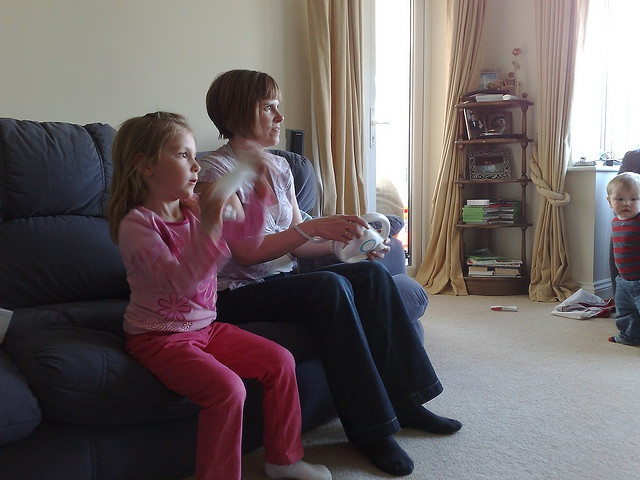Describe the objects in this image and their specific colors. I can see couch in darkgray, black, and gray tones, people in darkgray, black, gray, and maroon tones, people in darkgray, maroon, black, purple, and gray tones, refrigerator in darkgray, gray, and lightblue tones, and people in darkgray, black, gray, and maroon tones in this image. 